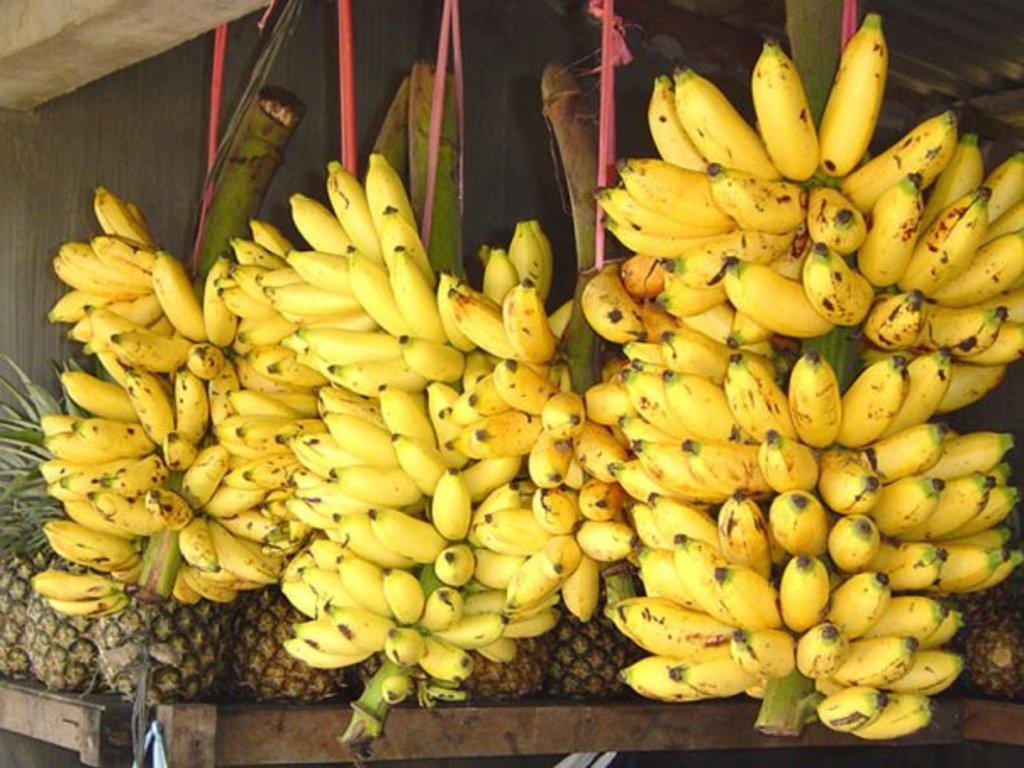What type of fruit can be seen in the image? There are bananas in the image. Where are the pineapples located in the image? The pineapples are on a table in the image. Why is the sofa crying in the image? There is no sofa present in the image, and therefore it cannot be crying. 